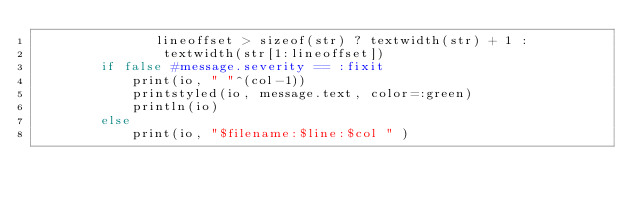Convert code to text. <code><loc_0><loc_0><loc_500><loc_500><_Julia_>               lineoffset > sizeof(str) ? textwidth(str) + 1 :
                textwidth(str[1:lineoffset])
        if false #message.severity == :fixit
            print(io, " "^(col-1))
            printstyled(io, message.text, color=:green)
            println(io)
        else
            print(io, "$filename:$line:$col " )</code> 